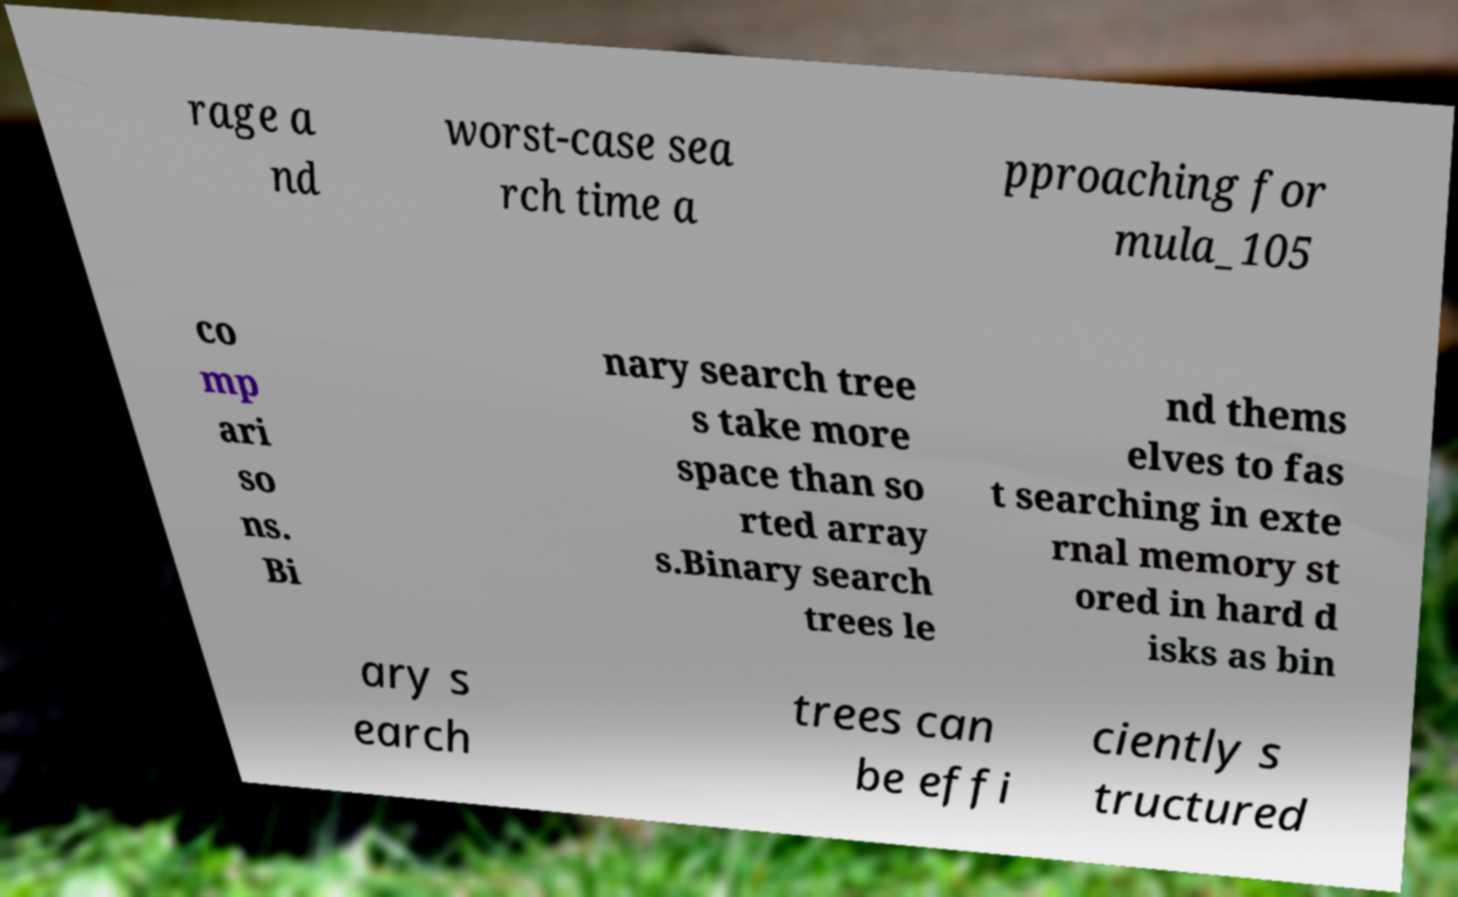I need the written content from this picture converted into text. Can you do that? rage a nd worst-case sea rch time a pproaching for mula_105 co mp ari so ns. Bi nary search tree s take more space than so rted array s.Binary search trees le nd thems elves to fas t searching in exte rnal memory st ored in hard d isks as bin ary s earch trees can be effi ciently s tructured 